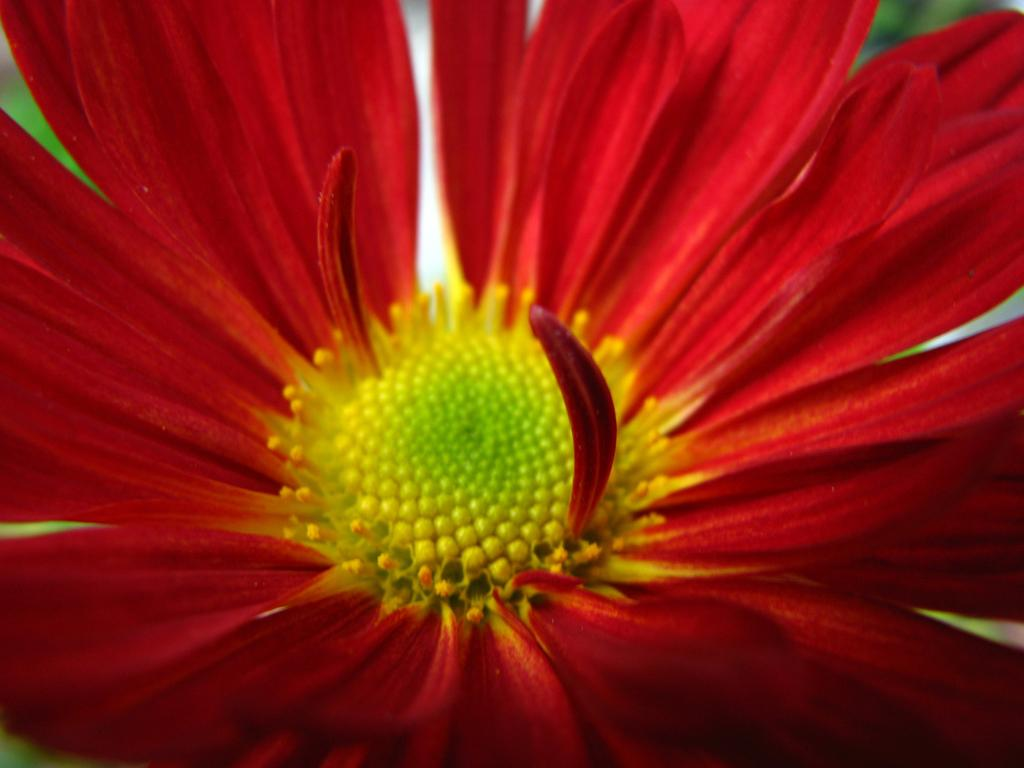What type of flower is in the image? There is a red color flower in the image. What can be seen in the background of the image? There is greenery in the background of the image. What type of square object is being pulled by the farmer in the image? There is no farmer or square object present in the image. 